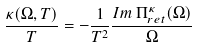<formula> <loc_0><loc_0><loc_500><loc_500>\frac { \kappa ( \Omega , T ) } { T } = - \frac { 1 } { T ^ { 2 } } \frac { I m \, \Pi ^ { \kappa } _ { r e t } ( \Omega ) } { \Omega }</formula> 